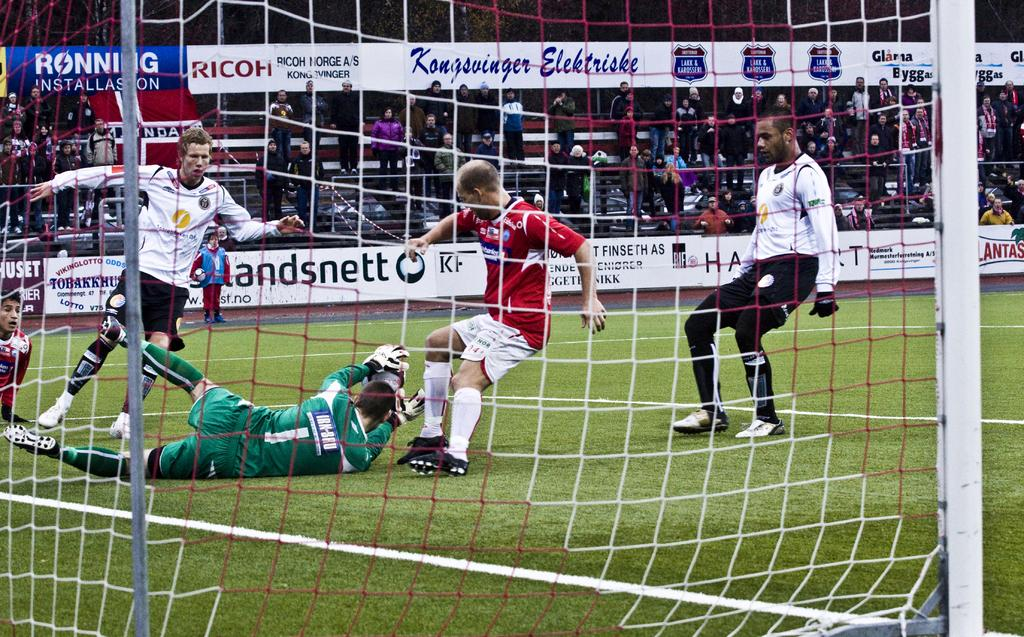<image>
Give a short and clear explanation of the subsequent image. a soccer game with the plyaer number 1 in green on the ground trying to block a shot 